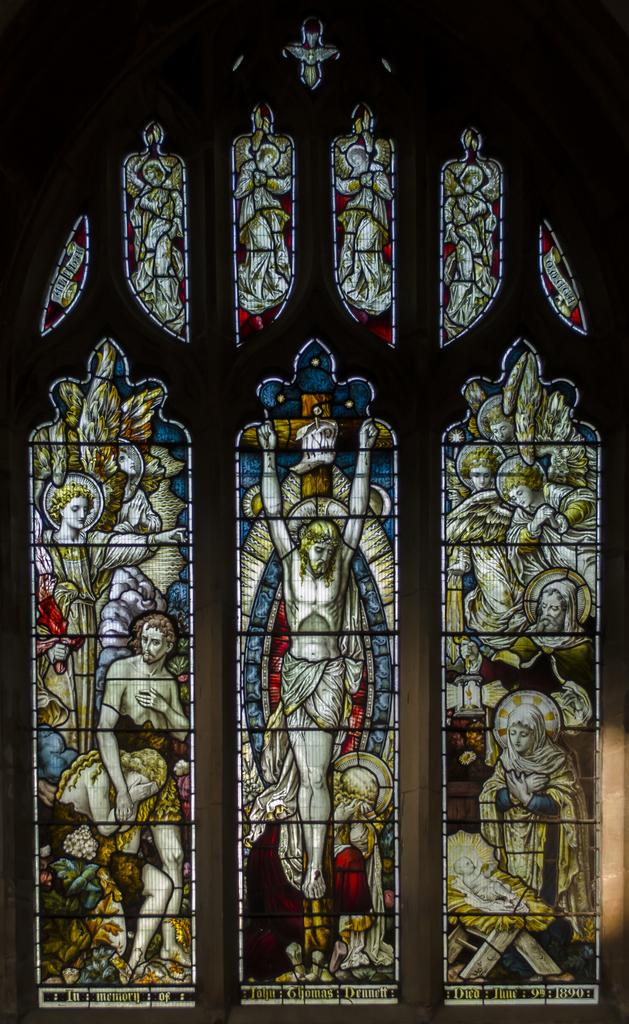What can be seen in the image that allows light to enter a room? There are windows in the image. Can you describe the appearance of the windows? The windows have a design. How much sand is being pushed through the windows in the image? There is no sand or pushing action present in the image; it only features windows with a design. 